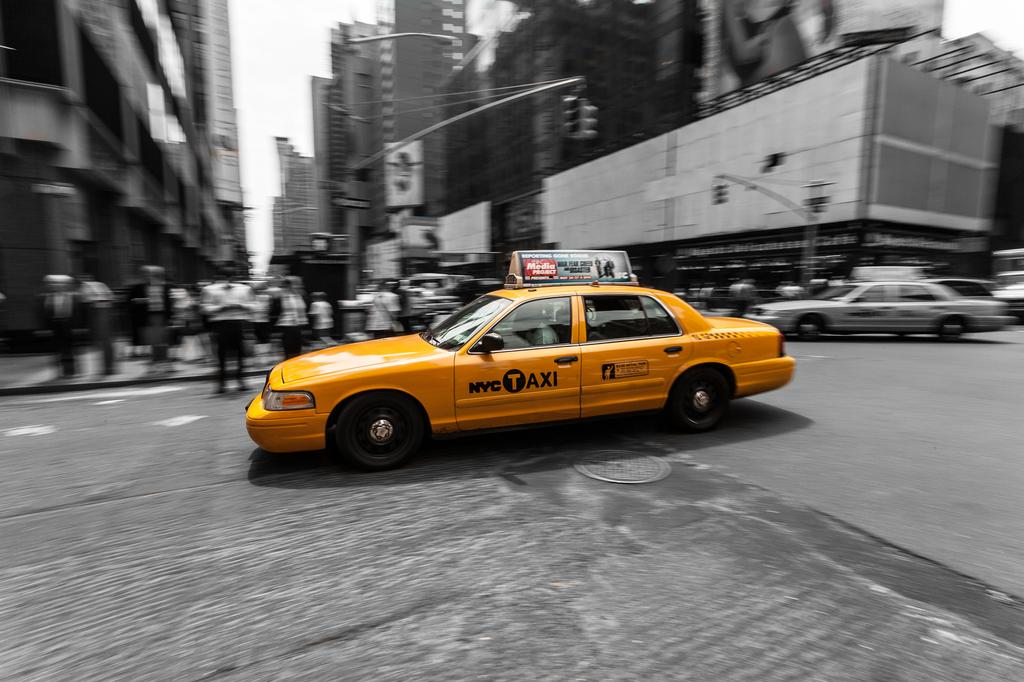Provide a one-sentence caption for the provided image. a taxi that is in the middle of the street. 